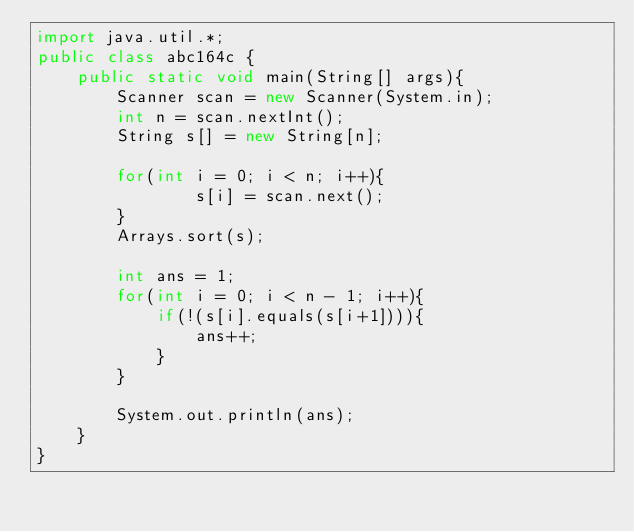<code> <loc_0><loc_0><loc_500><loc_500><_Java_>import java.util.*;
public class abc164c {
    public static void main(String[] args){
        Scanner scan = new Scanner(System.in);
        int n = scan.nextInt();
        String s[] = new String[n];

        for(int i = 0; i < n; i++){
                s[i] = scan.next();
        }
        Arrays.sort(s);

        int ans = 1;
        for(int i = 0; i < n - 1; i++){
            if(!(s[i].equals(s[i+1]))){
                ans++;
            }
        }

        System.out.println(ans);
    }
}</code> 